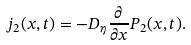Convert formula to latex. <formula><loc_0><loc_0><loc_500><loc_500>j _ { 2 } ( x , t ) = - D _ { \eta } \frac { \partial } { \partial x } P _ { 2 } ( x , t ) .</formula> 